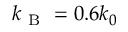<formula> <loc_0><loc_0><loc_500><loc_500>k _ { B } = 0 . 6 k _ { 0 }</formula> 